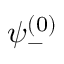Convert formula to latex. <formula><loc_0><loc_0><loc_500><loc_500>\psi _ { - } ^ { ( 0 ) }</formula> 